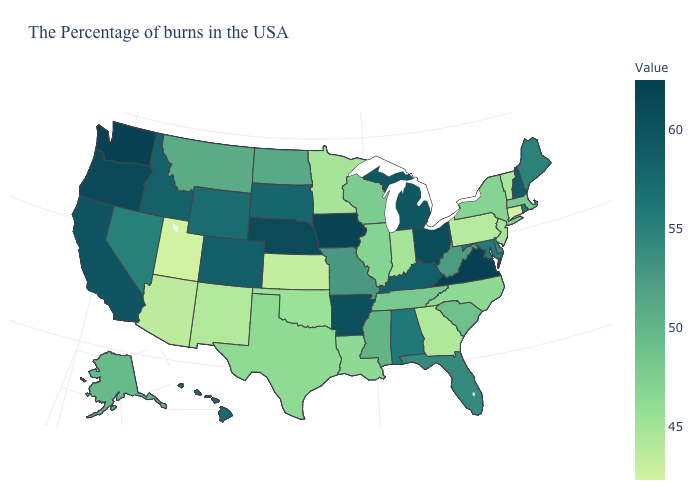Does Iowa have the highest value in the MidWest?
Short answer required. Yes. Among the states that border Rhode Island , which have the lowest value?
Answer briefly. Connecticut. Among the states that border Nevada , which have the lowest value?
Concise answer only. Utah. Among the states that border Maryland , does West Virginia have the lowest value?
Give a very brief answer. No. Does North Dakota have a higher value than Oklahoma?
Concise answer only. Yes. Does Virginia have the lowest value in the USA?
Give a very brief answer. No. Is the legend a continuous bar?
Answer briefly. Yes. Does Iowa have the highest value in the MidWest?
Answer briefly. Yes. Does New Jersey have a lower value than Massachusetts?
Write a very short answer. Yes. 